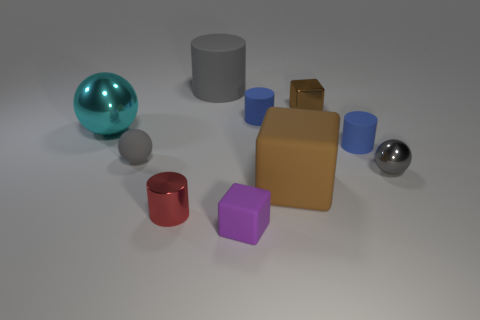There is another sphere that is the same color as the tiny matte ball; what is its size?
Your answer should be compact. Small. There is a large thing that is the same shape as the tiny gray rubber thing; what is its material?
Your answer should be very brief. Metal. How many other cyan shiny cubes have the same size as the metal cube?
Ensure brevity in your answer.  0. How many large gray rubber objects are there?
Make the answer very short. 1. Is the material of the tiny brown thing the same as the tiny cylinder in front of the gray shiny thing?
Your answer should be compact. Yes. What number of gray objects are small balls or big matte blocks?
Your answer should be compact. 2. The sphere that is the same material as the big brown cube is what size?
Your response must be concise. Small. How many purple things are the same shape as the brown matte object?
Your answer should be compact. 1. Are there more small matte things that are to the right of the purple cube than tiny shiny spheres on the left side of the tiny metal cylinder?
Ensure brevity in your answer.  Yes. Do the shiny cube and the matte block behind the metal cylinder have the same color?
Provide a succinct answer. Yes. 